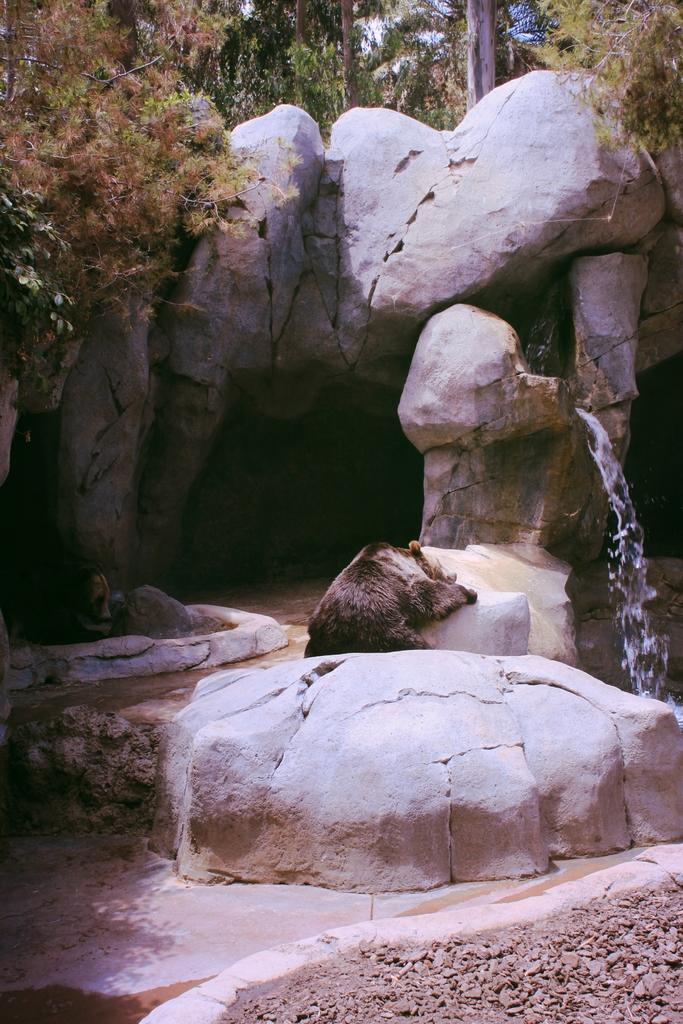How many bears are present in the image? There are two bears in the image. What is happening with the rocks in the image? Water is falling from rocks in the image. What can be seen in the background of the image? There are trees in the background of the image. What type of toothpaste is the bear using in the image? There is no toothpaste present in the image; the bears are not engaged in any activity related to toothpaste. 